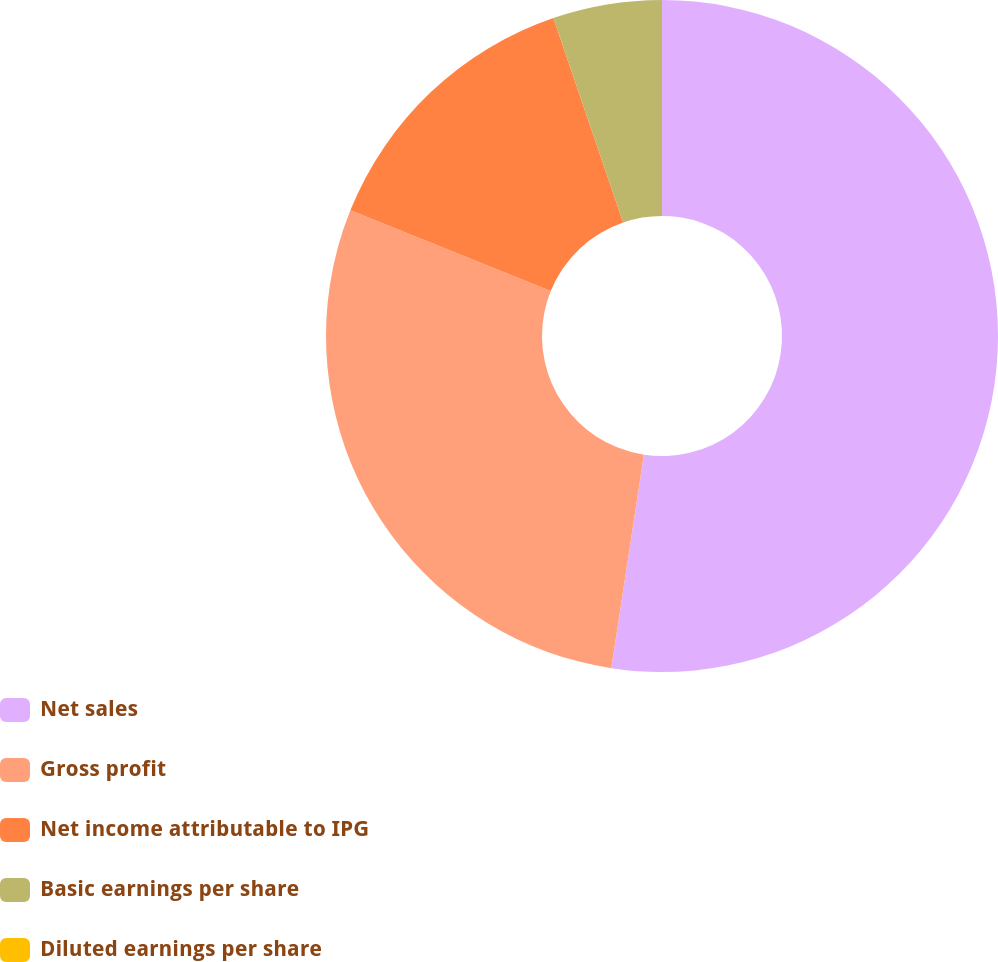<chart> <loc_0><loc_0><loc_500><loc_500><pie_chart><fcel>Net sales<fcel>Gross profit<fcel>Net income attributable to IPG<fcel>Basic earnings per share<fcel>Diluted earnings per share<nl><fcel>52.41%<fcel>28.69%<fcel>13.66%<fcel>5.24%<fcel>0.0%<nl></chart> 